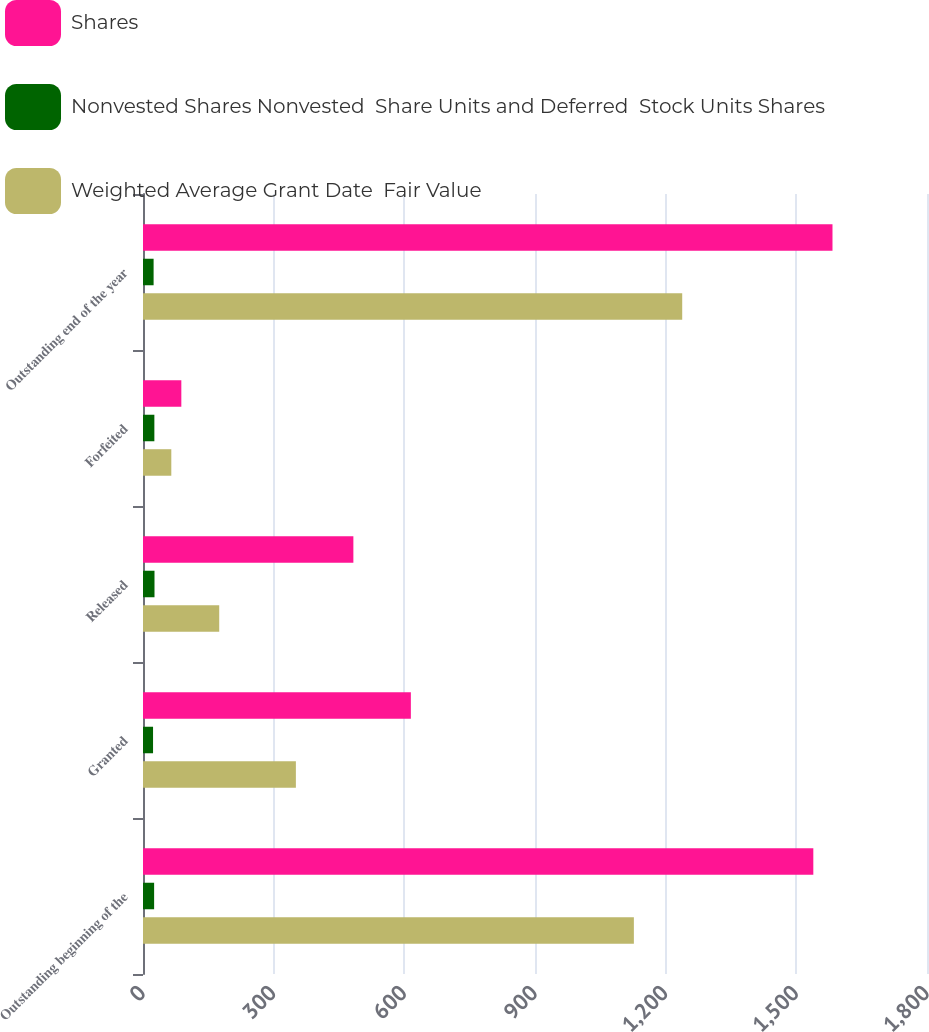<chart> <loc_0><loc_0><loc_500><loc_500><stacked_bar_chart><ecel><fcel>Outstanding beginning of the<fcel>Granted<fcel>Released<fcel>Forfeited<fcel>Outstanding end of the year<nl><fcel>Shares<fcel>1539<fcel>615<fcel>483<fcel>88<fcel>1583<nl><fcel>Nonvested Shares Nonvested  Share Units and Deferred  Stock Units Shares<fcel>25.54<fcel>23.07<fcel>26.4<fcel>26.1<fcel>24.34<nl><fcel>Weighted Average Grant Date  Fair Value<fcel>1127<fcel>351<fcel>175<fcel>65<fcel>1238<nl></chart> 